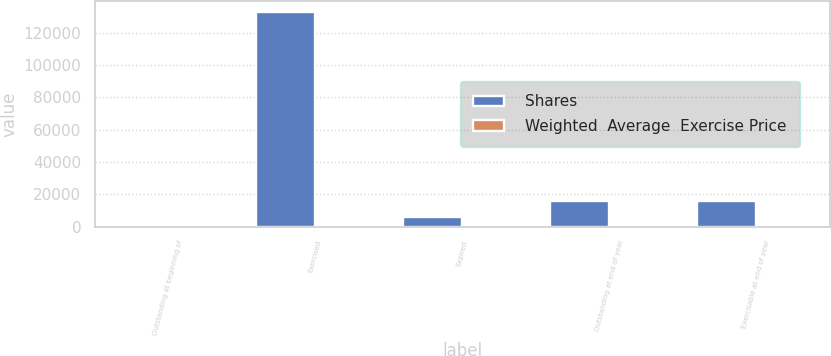Convert chart to OTSL. <chart><loc_0><loc_0><loc_500><loc_500><stacked_bar_chart><ecel><fcel>Outstanding at beginning of<fcel>Exercised<fcel>Expired<fcel>Outstanding at end of year<fcel>Exercisable at end of year<nl><fcel>Shares<fcel>41.25<fcel>132905<fcel>5941<fcel>15705<fcel>15705<nl><fcel>Weighted  Average  Exercise Price<fcel>35.96<fcel>36.86<fcel>41.25<fcel>26.34<fcel>26.34<nl></chart> 